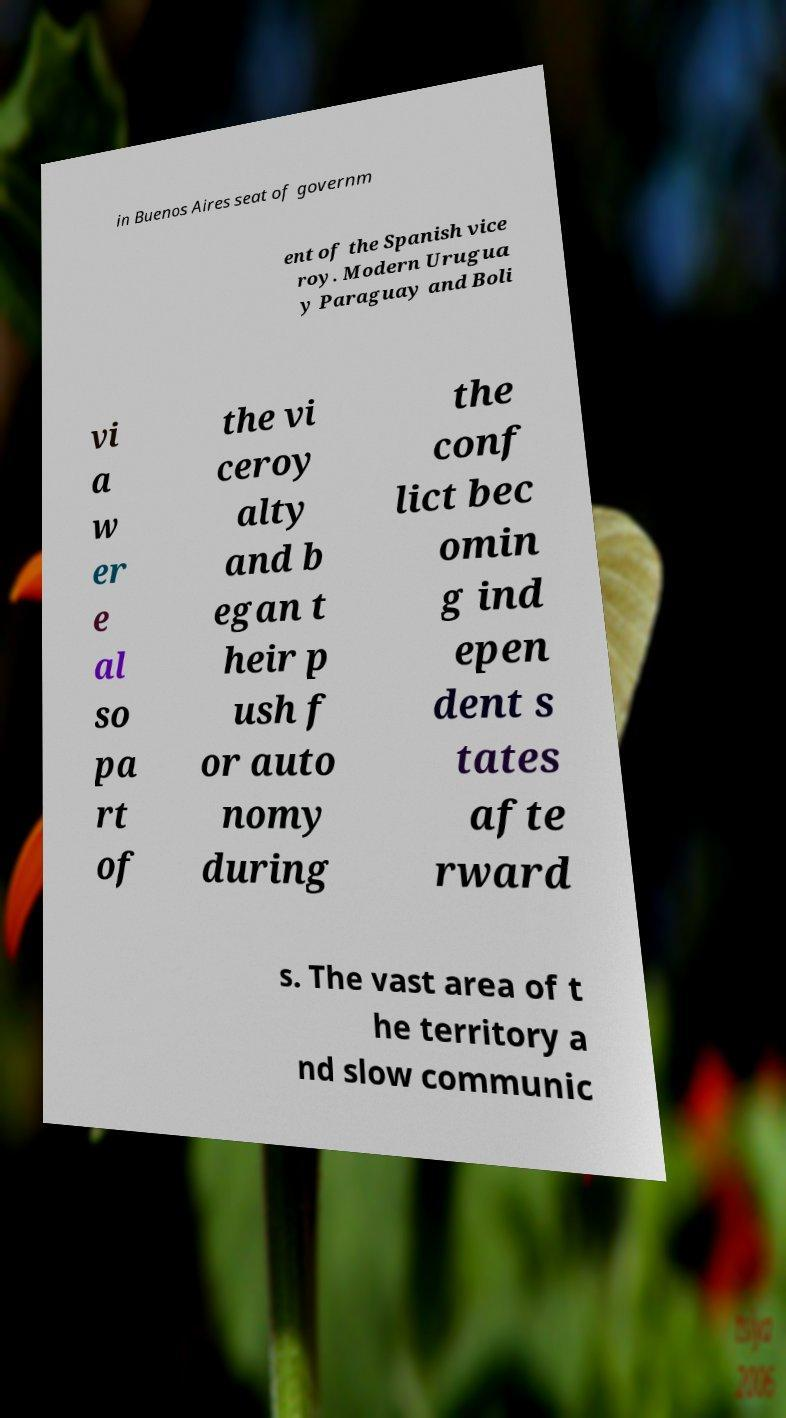Can you accurately transcribe the text from the provided image for me? in Buenos Aires seat of governm ent of the Spanish vice roy. Modern Urugua y Paraguay and Boli vi a w er e al so pa rt of the vi ceroy alty and b egan t heir p ush f or auto nomy during the conf lict bec omin g ind epen dent s tates afte rward s. The vast area of t he territory a nd slow communic 